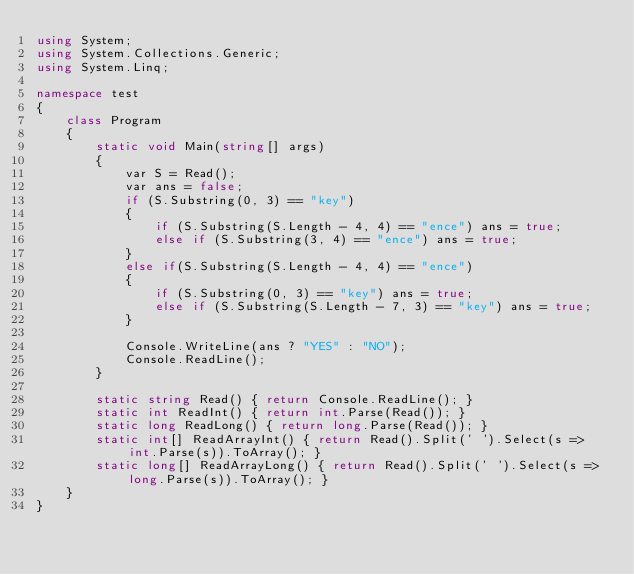<code> <loc_0><loc_0><loc_500><loc_500><_C#_>using System;
using System.Collections.Generic;
using System.Linq;

namespace test
{
    class Program
    {
        static void Main(string[] args)
        {
            var S = Read();
            var ans = false;
            if (S.Substring(0, 3) == "key")
            {
                if (S.Substring(S.Length - 4, 4) == "ence") ans = true;
                else if (S.Substring(3, 4) == "ence") ans = true;
            }
            else if(S.Substring(S.Length - 4, 4) == "ence")
            {
                if (S.Substring(0, 3) == "key") ans = true;
                else if (S.Substring(S.Length - 7, 3) == "key") ans = true;
            }

            Console.WriteLine(ans ? "YES" : "NO");
            Console.ReadLine();
        }

        static string Read() { return Console.ReadLine(); }
        static int ReadInt() { return int.Parse(Read()); }
        static long ReadLong() { return long.Parse(Read()); }
        static int[] ReadArrayInt() { return Read().Split(' ').Select(s => int.Parse(s)).ToArray(); }
        static long[] ReadArrayLong() { return Read().Split(' ').Select(s => long.Parse(s)).ToArray(); }
    }
}</code> 